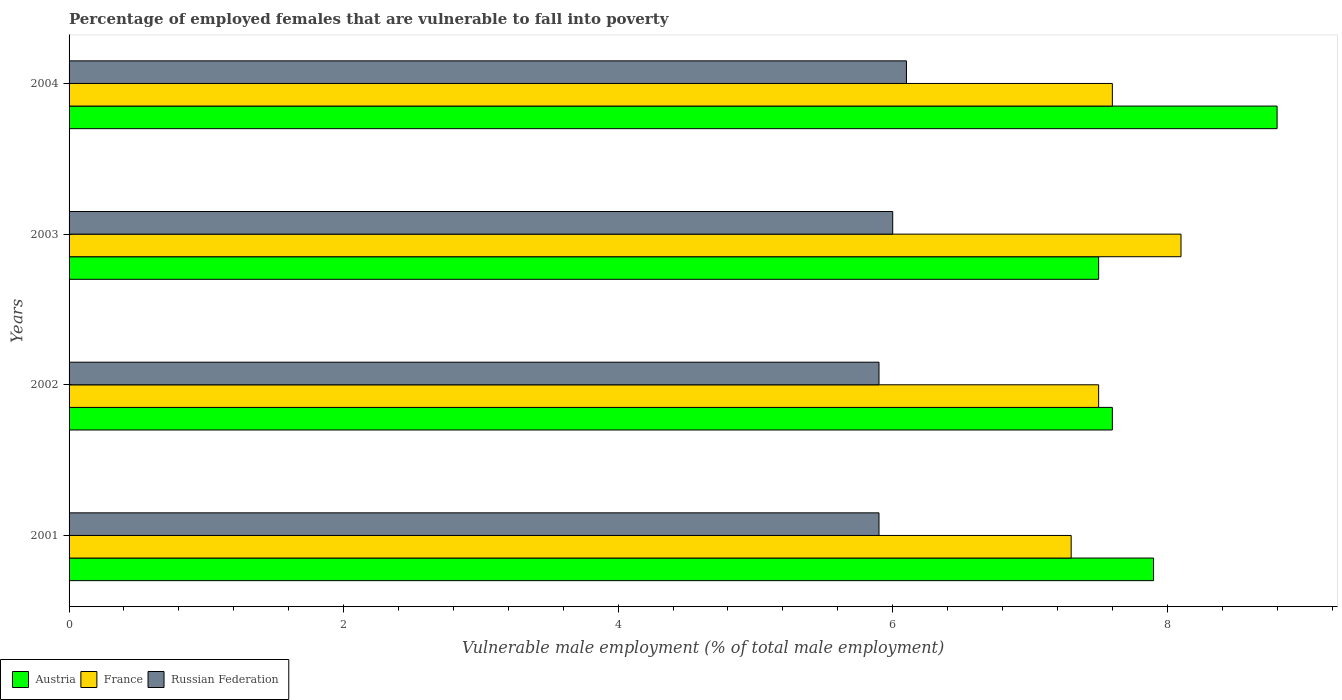Are the number of bars per tick equal to the number of legend labels?
Offer a terse response. Yes. How many bars are there on the 4th tick from the top?
Your answer should be compact. 3. How many bars are there on the 3rd tick from the bottom?
Ensure brevity in your answer.  3. What is the label of the 1st group of bars from the top?
Make the answer very short. 2004. What is the percentage of employed females who are vulnerable to fall into poverty in Russian Federation in 2001?
Ensure brevity in your answer.  5.9. Across all years, what is the maximum percentage of employed females who are vulnerable to fall into poverty in Austria?
Offer a very short reply. 8.8. In which year was the percentage of employed females who are vulnerable to fall into poverty in Austria maximum?
Offer a terse response. 2004. What is the total percentage of employed females who are vulnerable to fall into poverty in France in the graph?
Provide a short and direct response. 30.5. What is the difference between the percentage of employed females who are vulnerable to fall into poverty in Austria in 2002 and that in 2003?
Your answer should be compact. 0.1. What is the difference between the percentage of employed females who are vulnerable to fall into poverty in Austria in 2004 and the percentage of employed females who are vulnerable to fall into poverty in France in 2001?
Offer a very short reply. 1.5. What is the average percentage of employed females who are vulnerable to fall into poverty in France per year?
Give a very brief answer. 7.63. In the year 2003, what is the difference between the percentage of employed females who are vulnerable to fall into poverty in Austria and percentage of employed females who are vulnerable to fall into poverty in Russian Federation?
Offer a terse response. 1.5. What is the ratio of the percentage of employed females who are vulnerable to fall into poverty in Austria in 2002 to that in 2004?
Make the answer very short. 0.86. Is the difference between the percentage of employed females who are vulnerable to fall into poverty in Austria in 2001 and 2002 greater than the difference between the percentage of employed females who are vulnerable to fall into poverty in Russian Federation in 2001 and 2002?
Your answer should be compact. Yes. What is the difference between the highest and the second highest percentage of employed females who are vulnerable to fall into poverty in Austria?
Your response must be concise. 0.9. What is the difference between the highest and the lowest percentage of employed females who are vulnerable to fall into poverty in Austria?
Offer a very short reply. 1.3. Is the sum of the percentage of employed females who are vulnerable to fall into poverty in Russian Federation in 2003 and 2004 greater than the maximum percentage of employed females who are vulnerable to fall into poverty in France across all years?
Make the answer very short. Yes. What does the 1st bar from the top in 2002 represents?
Provide a short and direct response. Russian Federation. How many bars are there?
Your response must be concise. 12. How many years are there in the graph?
Offer a terse response. 4. Are the values on the major ticks of X-axis written in scientific E-notation?
Your answer should be compact. No. Does the graph contain grids?
Provide a succinct answer. No. Where does the legend appear in the graph?
Give a very brief answer. Bottom left. How are the legend labels stacked?
Keep it short and to the point. Horizontal. What is the title of the graph?
Your response must be concise. Percentage of employed females that are vulnerable to fall into poverty. What is the label or title of the X-axis?
Your answer should be compact. Vulnerable male employment (% of total male employment). What is the label or title of the Y-axis?
Offer a very short reply. Years. What is the Vulnerable male employment (% of total male employment) of Austria in 2001?
Keep it short and to the point. 7.9. What is the Vulnerable male employment (% of total male employment) in France in 2001?
Provide a short and direct response. 7.3. What is the Vulnerable male employment (% of total male employment) of Russian Federation in 2001?
Your answer should be very brief. 5.9. What is the Vulnerable male employment (% of total male employment) of Austria in 2002?
Provide a succinct answer. 7.6. What is the Vulnerable male employment (% of total male employment) in France in 2002?
Keep it short and to the point. 7.5. What is the Vulnerable male employment (% of total male employment) of Russian Federation in 2002?
Provide a short and direct response. 5.9. What is the Vulnerable male employment (% of total male employment) in France in 2003?
Offer a terse response. 8.1. What is the Vulnerable male employment (% of total male employment) in Russian Federation in 2003?
Your answer should be compact. 6. What is the Vulnerable male employment (% of total male employment) of Austria in 2004?
Ensure brevity in your answer.  8.8. What is the Vulnerable male employment (% of total male employment) in France in 2004?
Your answer should be compact. 7.6. What is the Vulnerable male employment (% of total male employment) of Russian Federation in 2004?
Offer a very short reply. 6.1. Across all years, what is the maximum Vulnerable male employment (% of total male employment) of Austria?
Offer a terse response. 8.8. Across all years, what is the maximum Vulnerable male employment (% of total male employment) in France?
Your answer should be very brief. 8.1. Across all years, what is the maximum Vulnerable male employment (% of total male employment) of Russian Federation?
Your response must be concise. 6.1. Across all years, what is the minimum Vulnerable male employment (% of total male employment) of Austria?
Your response must be concise. 7.5. Across all years, what is the minimum Vulnerable male employment (% of total male employment) in France?
Provide a short and direct response. 7.3. Across all years, what is the minimum Vulnerable male employment (% of total male employment) of Russian Federation?
Your answer should be very brief. 5.9. What is the total Vulnerable male employment (% of total male employment) of Austria in the graph?
Provide a short and direct response. 31.8. What is the total Vulnerable male employment (% of total male employment) of France in the graph?
Ensure brevity in your answer.  30.5. What is the total Vulnerable male employment (% of total male employment) of Russian Federation in the graph?
Keep it short and to the point. 23.9. What is the difference between the Vulnerable male employment (% of total male employment) in France in 2001 and that in 2002?
Keep it short and to the point. -0.2. What is the difference between the Vulnerable male employment (% of total male employment) of Austria in 2001 and that in 2004?
Offer a terse response. -0.9. What is the difference between the Vulnerable male employment (% of total male employment) in Austria in 2002 and that in 2003?
Offer a very short reply. 0.1. What is the difference between the Vulnerable male employment (% of total male employment) in France in 2002 and that in 2003?
Give a very brief answer. -0.6. What is the difference between the Vulnerable male employment (% of total male employment) of Austria in 2002 and that in 2004?
Provide a succinct answer. -1.2. What is the difference between the Vulnerable male employment (% of total male employment) of France in 2003 and that in 2004?
Provide a short and direct response. 0.5. What is the difference between the Vulnerable male employment (% of total male employment) of Russian Federation in 2003 and that in 2004?
Make the answer very short. -0.1. What is the difference between the Vulnerable male employment (% of total male employment) of Austria in 2001 and the Vulnerable male employment (% of total male employment) of France in 2002?
Offer a terse response. 0.4. What is the difference between the Vulnerable male employment (% of total male employment) in France in 2001 and the Vulnerable male employment (% of total male employment) in Russian Federation in 2002?
Make the answer very short. 1.4. What is the difference between the Vulnerable male employment (% of total male employment) in Austria in 2001 and the Vulnerable male employment (% of total male employment) in France in 2003?
Offer a very short reply. -0.2. What is the difference between the Vulnerable male employment (% of total male employment) in France in 2001 and the Vulnerable male employment (% of total male employment) in Russian Federation in 2004?
Make the answer very short. 1.2. What is the difference between the Vulnerable male employment (% of total male employment) of Austria in 2002 and the Vulnerable male employment (% of total male employment) of Russian Federation in 2003?
Your response must be concise. 1.6. What is the difference between the Vulnerable male employment (% of total male employment) of France in 2002 and the Vulnerable male employment (% of total male employment) of Russian Federation in 2003?
Your answer should be compact. 1.5. What is the difference between the Vulnerable male employment (% of total male employment) of France in 2002 and the Vulnerable male employment (% of total male employment) of Russian Federation in 2004?
Offer a very short reply. 1.4. What is the difference between the Vulnerable male employment (% of total male employment) in France in 2003 and the Vulnerable male employment (% of total male employment) in Russian Federation in 2004?
Ensure brevity in your answer.  2. What is the average Vulnerable male employment (% of total male employment) in Austria per year?
Make the answer very short. 7.95. What is the average Vulnerable male employment (% of total male employment) in France per year?
Provide a succinct answer. 7.62. What is the average Vulnerable male employment (% of total male employment) of Russian Federation per year?
Your answer should be very brief. 5.97. In the year 2001, what is the difference between the Vulnerable male employment (% of total male employment) in France and Vulnerable male employment (% of total male employment) in Russian Federation?
Provide a short and direct response. 1.4. In the year 2002, what is the difference between the Vulnerable male employment (% of total male employment) in France and Vulnerable male employment (% of total male employment) in Russian Federation?
Ensure brevity in your answer.  1.6. In the year 2003, what is the difference between the Vulnerable male employment (% of total male employment) in Austria and Vulnerable male employment (% of total male employment) in Russian Federation?
Your answer should be very brief. 1.5. In the year 2004, what is the difference between the Vulnerable male employment (% of total male employment) in France and Vulnerable male employment (% of total male employment) in Russian Federation?
Your response must be concise. 1.5. What is the ratio of the Vulnerable male employment (% of total male employment) of Austria in 2001 to that in 2002?
Provide a succinct answer. 1.04. What is the ratio of the Vulnerable male employment (% of total male employment) in France in 2001 to that in 2002?
Your answer should be very brief. 0.97. What is the ratio of the Vulnerable male employment (% of total male employment) in Russian Federation in 2001 to that in 2002?
Your answer should be very brief. 1. What is the ratio of the Vulnerable male employment (% of total male employment) of Austria in 2001 to that in 2003?
Provide a succinct answer. 1.05. What is the ratio of the Vulnerable male employment (% of total male employment) in France in 2001 to that in 2003?
Give a very brief answer. 0.9. What is the ratio of the Vulnerable male employment (% of total male employment) in Russian Federation in 2001 to that in 2003?
Your response must be concise. 0.98. What is the ratio of the Vulnerable male employment (% of total male employment) of Austria in 2001 to that in 2004?
Make the answer very short. 0.9. What is the ratio of the Vulnerable male employment (% of total male employment) of France in 2001 to that in 2004?
Your response must be concise. 0.96. What is the ratio of the Vulnerable male employment (% of total male employment) in Russian Federation in 2001 to that in 2004?
Give a very brief answer. 0.97. What is the ratio of the Vulnerable male employment (% of total male employment) of Austria in 2002 to that in 2003?
Offer a terse response. 1.01. What is the ratio of the Vulnerable male employment (% of total male employment) in France in 2002 to that in 2003?
Your response must be concise. 0.93. What is the ratio of the Vulnerable male employment (% of total male employment) of Russian Federation in 2002 to that in 2003?
Your response must be concise. 0.98. What is the ratio of the Vulnerable male employment (% of total male employment) in Austria in 2002 to that in 2004?
Offer a terse response. 0.86. What is the ratio of the Vulnerable male employment (% of total male employment) in France in 2002 to that in 2004?
Your answer should be very brief. 0.99. What is the ratio of the Vulnerable male employment (% of total male employment) of Russian Federation in 2002 to that in 2004?
Keep it short and to the point. 0.97. What is the ratio of the Vulnerable male employment (% of total male employment) of Austria in 2003 to that in 2004?
Offer a terse response. 0.85. What is the ratio of the Vulnerable male employment (% of total male employment) in France in 2003 to that in 2004?
Provide a succinct answer. 1.07. What is the ratio of the Vulnerable male employment (% of total male employment) of Russian Federation in 2003 to that in 2004?
Keep it short and to the point. 0.98. What is the difference between the highest and the second highest Vulnerable male employment (% of total male employment) in Austria?
Provide a short and direct response. 0.9. What is the difference between the highest and the second highest Vulnerable male employment (% of total male employment) in Russian Federation?
Keep it short and to the point. 0.1. 